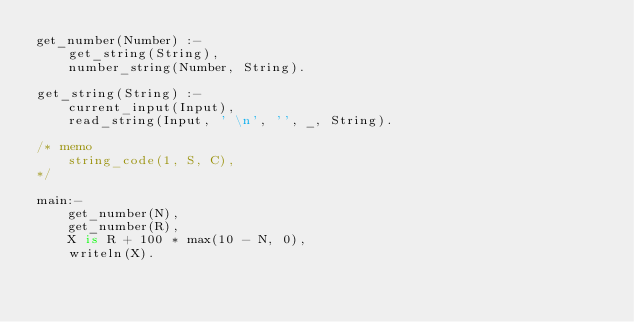Convert code to text. <code><loc_0><loc_0><loc_500><loc_500><_Prolog_>get_number(Number) :-
    get_string(String),
    number_string(Number, String).

get_string(String) :-
    current_input(Input),
    read_string(Input, ' \n', '', _, String).

/* memo
    string_code(1, S, C),
*/

main:-
    get_number(N),
    get_number(R),
    X is R + 100 * max(10 - N, 0),
    writeln(X).
</code> 